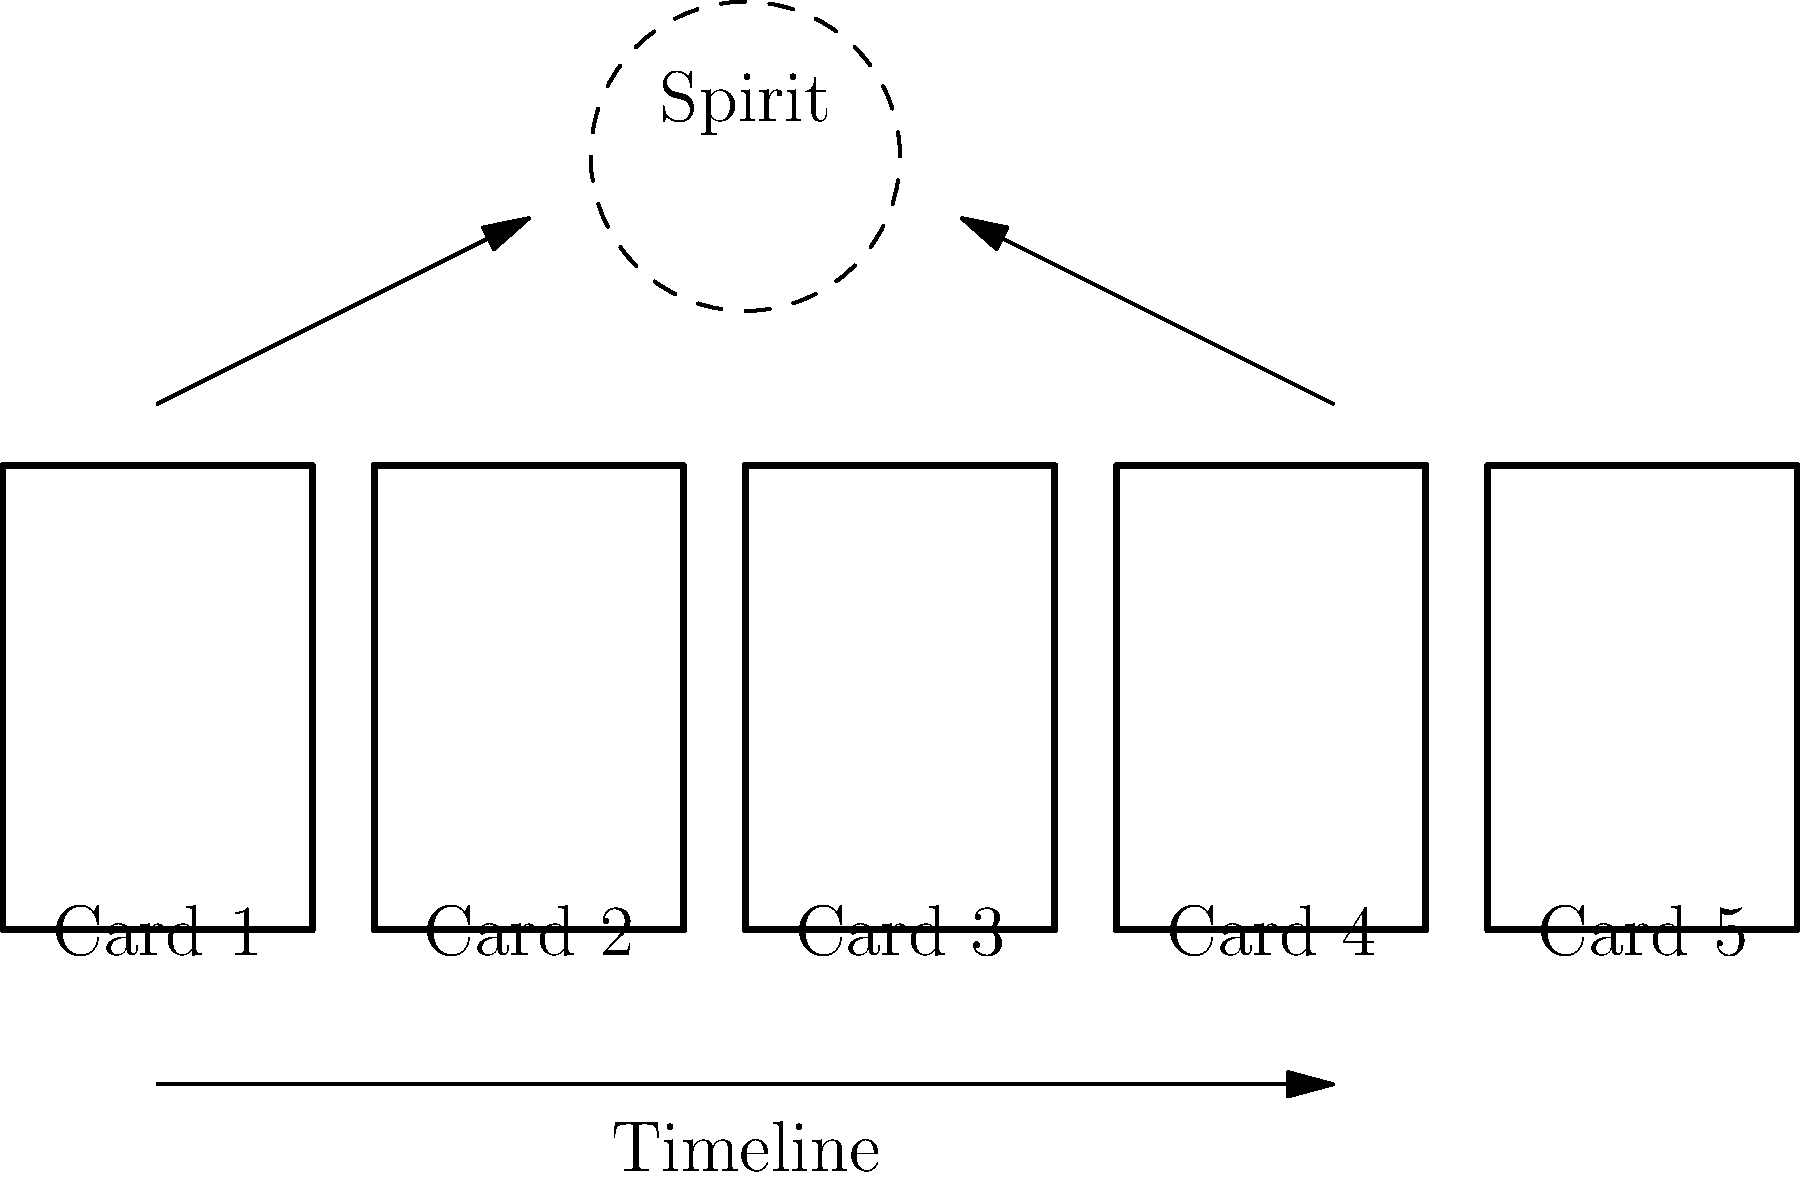In the given tarot spread diagram, which card position is most closely associated with the querent's spiritual growth and connection to higher consciousness, and why is this significant in a Celtic Cross reading? To answer this question, let's analyze the tarot spread diagram step-by-step:

1. The diagram shows a 5-card spread arranged horizontally, representing a timeline.

2. Above the spread, there's a dashed circle labeled "Spirit," which symbolizes the realm of higher consciousness and spiritual growth.

3. Two arrows point from the leftmost (Card 1) and rightmost (Card 5) cards towards the "Spirit" circle.

4. In a Celtic Cross reading, the card positions have specific meanings:
   - Card 1 typically represents the present situation or the querent's current state.
   - Card 5 often signifies the potential outcome or future influences.

5. The arrows connecting these cards to the "Spirit" circle suggest a connection between the querent's journey (from present to future) and their spiritual growth.

6. However, the card most closely associated with spiritual growth and higher consciousness would be Card 5 because:
   - It's at the end of the timeline, indicating a culmination or result of the querent's journey.
   - In Celtic Cross readings, this position often represents hopes, fears, or potential outcomes, which can be closely tied to spiritual development.
   - Its proximity to the "Spirit" circle in the diagram emphasizes its connection to higher consciousness.

7. The significance of this in a Celtic Cross reading is that it encourages the querent to view their journey as a spiritual process, with the outcome (Card 5) being closely tied to their spiritual growth and connection to higher realms of consciousness.

This interpretation allows for a holistic view of the querent's situation, emphasizing personal and spiritual development throughout the reading.
Answer: Card 5, representing potential outcomes and spiritual culmination in the Celtic Cross spread. 